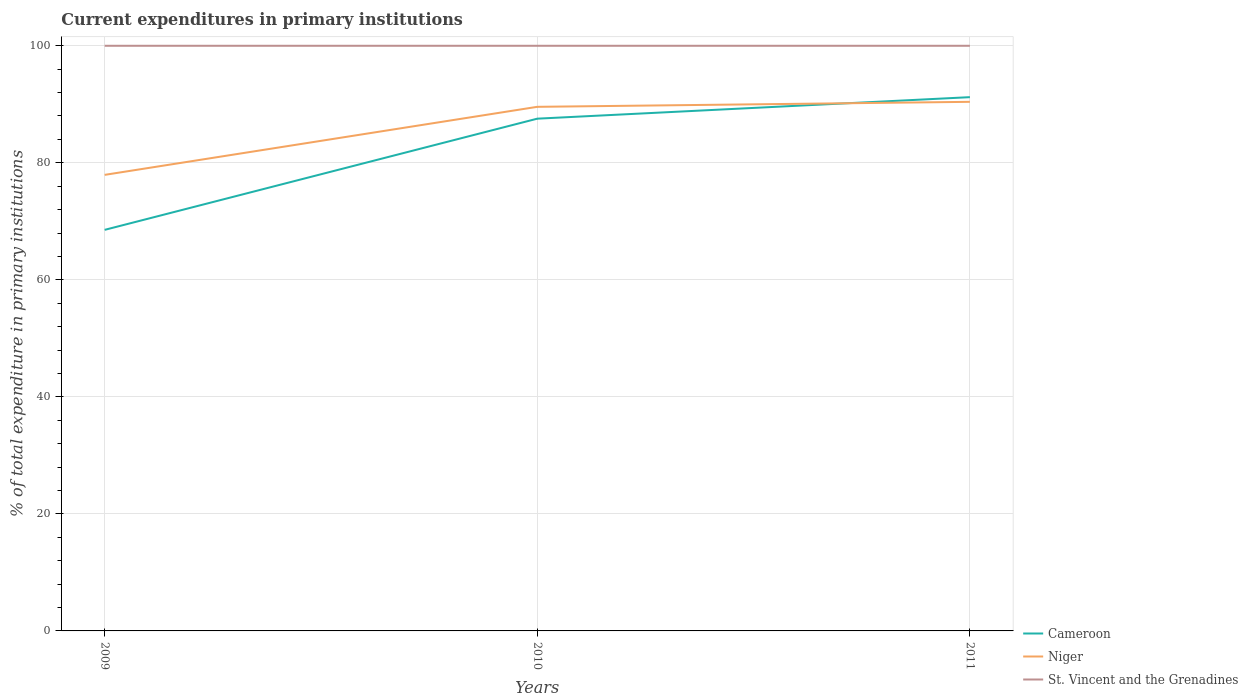Does the line corresponding to Cameroon intersect with the line corresponding to Niger?
Your answer should be very brief. Yes. Is the number of lines equal to the number of legend labels?
Offer a terse response. Yes. Across all years, what is the maximum current expenditures in primary institutions in St. Vincent and the Grenadines?
Ensure brevity in your answer.  100. What is the total current expenditures in primary institutions in Cameroon in the graph?
Make the answer very short. -22.68. What is the difference between the highest and the second highest current expenditures in primary institutions in St. Vincent and the Grenadines?
Your answer should be compact. 0. What is the difference between the highest and the lowest current expenditures in primary institutions in Niger?
Provide a short and direct response. 2. How many lines are there?
Provide a short and direct response. 3. How many years are there in the graph?
Provide a succinct answer. 3. What is the difference between two consecutive major ticks on the Y-axis?
Offer a very short reply. 20. Does the graph contain any zero values?
Your response must be concise. No. Where does the legend appear in the graph?
Your answer should be compact. Bottom right. What is the title of the graph?
Your answer should be very brief. Current expenditures in primary institutions. Does "Finland" appear as one of the legend labels in the graph?
Your answer should be very brief. No. What is the label or title of the Y-axis?
Offer a terse response. % of total expenditure in primary institutions. What is the % of total expenditure in primary institutions in Cameroon in 2009?
Give a very brief answer. 68.54. What is the % of total expenditure in primary institutions in Niger in 2009?
Ensure brevity in your answer.  77.94. What is the % of total expenditure in primary institutions of Cameroon in 2010?
Offer a terse response. 87.54. What is the % of total expenditure in primary institutions of Niger in 2010?
Provide a succinct answer. 89.57. What is the % of total expenditure in primary institutions in Cameroon in 2011?
Provide a succinct answer. 91.22. What is the % of total expenditure in primary institutions in Niger in 2011?
Keep it short and to the point. 90.42. What is the % of total expenditure in primary institutions in St. Vincent and the Grenadines in 2011?
Make the answer very short. 100. Across all years, what is the maximum % of total expenditure in primary institutions in Cameroon?
Offer a very short reply. 91.22. Across all years, what is the maximum % of total expenditure in primary institutions in Niger?
Make the answer very short. 90.42. Across all years, what is the minimum % of total expenditure in primary institutions in Cameroon?
Offer a very short reply. 68.54. Across all years, what is the minimum % of total expenditure in primary institutions of Niger?
Give a very brief answer. 77.94. Across all years, what is the minimum % of total expenditure in primary institutions of St. Vincent and the Grenadines?
Provide a succinct answer. 100. What is the total % of total expenditure in primary institutions in Cameroon in the graph?
Your answer should be very brief. 247.3. What is the total % of total expenditure in primary institutions in Niger in the graph?
Ensure brevity in your answer.  257.93. What is the total % of total expenditure in primary institutions in St. Vincent and the Grenadines in the graph?
Provide a short and direct response. 300. What is the difference between the % of total expenditure in primary institutions of Cameroon in 2009 and that in 2010?
Provide a short and direct response. -19. What is the difference between the % of total expenditure in primary institutions of Niger in 2009 and that in 2010?
Offer a terse response. -11.63. What is the difference between the % of total expenditure in primary institutions in St. Vincent and the Grenadines in 2009 and that in 2010?
Your answer should be compact. 0. What is the difference between the % of total expenditure in primary institutions of Cameroon in 2009 and that in 2011?
Ensure brevity in your answer.  -22.68. What is the difference between the % of total expenditure in primary institutions of Niger in 2009 and that in 2011?
Provide a succinct answer. -12.48. What is the difference between the % of total expenditure in primary institutions of Cameroon in 2010 and that in 2011?
Keep it short and to the point. -3.68. What is the difference between the % of total expenditure in primary institutions in Niger in 2010 and that in 2011?
Your answer should be very brief. -0.85. What is the difference between the % of total expenditure in primary institutions in St. Vincent and the Grenadines in 2010 and that in 2011?
Give a very brief answer. 0. What is the difference between the % of total expenditure in primary institutions in Cameroon in 2009 and the % of total expenditure in primary institutions in Niger in 2010?
Make the answer very short. -21.03. What is the difference between the % of total expenditure in primary institutions in Cameroon in 2009 and the % of total expenditure in primary institutions in St. Vincent and the Grenadines in 2010?
Offer a terse response. -31.46. What is the difference between the % of total expenditure in primary institutions in Niger in 2009 and the % of total expenditure in primary institutions in St. Vincent and the Grenadines in 2010?
Your answer should be compact. -22.06. What is the difference between the % of total expenditure in primary institutions in Cameroon in 2009 and the % of total expenditure in primary institutions in Niger in 2011?
Your answer should be compact. -21.88. What is the difference between the % of total expenditure in primary institutions of Cameroon in 2009 and the % of total expenditure in primary institutions of St. Vincent and the Grenadines in 2011?
Keep it short and to the point. -31.46. What is the difference between the % of total expenditure in primary institutions of Niger in 2009 and the % of total expenditure in primary institutions of St. Vincent and the Grenadines in 2011?
Ensure brevity in your answer.  -22.06. What is the difference between the % of total expenditure in primary institutions of Cameroon in 2010 and the % of total expenditure in primary institutions of Niger in 2011?
Your answer should be very brief. -2.88. What is the difference between the % of total expenditure in primary institutions in Cameroon in 2010 and the % of total expenditure in primary institutions in St. Vincent and the Grenadines in 2011?
Give a very brief answer. -12.46. What is the difference between the % of total expenditure in primary institutions in Niger in 2010 and the % of total expenditure in primary institutions in St. Vincent and the Grenadines in 2011?
Ensure brevity in your answer.  -10.43. What is the average % of total expenditure in primary institutions in Cameroon per year?
Make the answer very short. 82.43. What is the average % of total expenditure in primary institutions of Niger per year?
Provide a short and direct response. 85.98. What is the average % of total expenditure in primary institutions in St. Vincent and the Grenadines per year?
Offer a terse response. 100. In the year 2009, what is the difference between the % of total expenditure in primary institutions of Cameroon and % of total expenditure in primary institutions of Niger?
Ensure brevity in your answer.  -9.4. In the year 2009, what is the difference between the % of total expenditure in primary institutions in Cameroon and % of total expenditure in primary institutions in St. Vincent and the Grenadines?
Ensure brevity in your answer.  -31.46. In the year 2009, what is the difference between the % of total expenditure in primary institutions of Niger and % of total expenditure in primary institutions of St. Vincent and the Grenadines?
Ensure brevity in your answer.  -22.06. In the year 2010, what is the difference between the % of total expenditure in primary institutions in Cameroon and % of total expenditure in primary institutions in Niger?
Provide a succinct answer. -2.03. In the year 2010, what is the difference between the % of total expenditure in primary institutions in Cameroon and % of total expenditure in primary institutions in St. Vincent and the Grenadines?
Your answer should be compact. -12.46. In the year 2010, what is the difference between the % of total expenditure in primary institutions in Niger and % of total expenditure in primary institutions in St. Vincent and the Grenadines?
Give a very brief answer. -10.43. In the year 2011, what is the difference between the % of total expenditure in primary institutions of Cameroon and % of total expenditure in primary institutions of Niger?
Keep it short and to the point. 0.8. In the year 2011, what is the difference between the % of total expenditure in primary institutions of Cameroon and % of total expenditure in primary institutions of St. Vincent and the Grenadines?
Offer a very short reply. -8.78. In the year 2011, what is the difference between the % of total expenditure in primary institutions of Niger and % of total expenditure in primary institutions of St. Vincent and the Grenadines?
Ensure brevity in your answer.  -9.58. What is the ratio of the % of total expenditure in primary institutions in Cameroon in 2009 to that in 2010?
Provide a short and direct response. 0.78. What is the ratio of the % of total expenditure in primary institutions of Niger in 2009 to that in 2010?
Ensure brevity in your answer.  0.87. What is the ratio of the % of total expenditure in primary institutions in Cameroon in 2009 to that in 2011?
Ensure brevity in your answer.  0.75. What is the ratio of the % of total expenditure in primary institutions in Niger in 2009 to that in 2011?
Provide a short and direct response. 0.86. What is the ratio of the % of total expenditure in primary institutions in Cameroon in 2010 to that in 2011?
Provide a succinct answer. 0.96. What is the ratio of the % of total expenditure in primary institutions of Niger in 2010 to that in 2011?
Ensure brevity in your answer.  0.99. What is the difference between the highest and the second highest % of total expenditure in primary institutions of Cameroon?
Ensure brevity in your answer.  3.68. What is the difference between the highest and the second highest % of total expenditure in primary institutions in Niger?
Provide a succinct answer. 0.85. What is the difference between the highest and the second highest % of total expenditure in primary institutions in St. Vincent and the Grenadines?
Provide a succinct answer. 0. What is the difference between the highest and the lowest % of total expenditure in primary institutions in Cameroon?
Offer a very short reply. 22.68. What is the difference between the highest and the lowest % of total expenditure in primary institutions of Niger?
Offer a terse response. 12.48. What is the difference between the highest and the lowest % of total expenditure in primary institutions of St. Vincent and the Grenadines?
Offer a terse response. 0. 